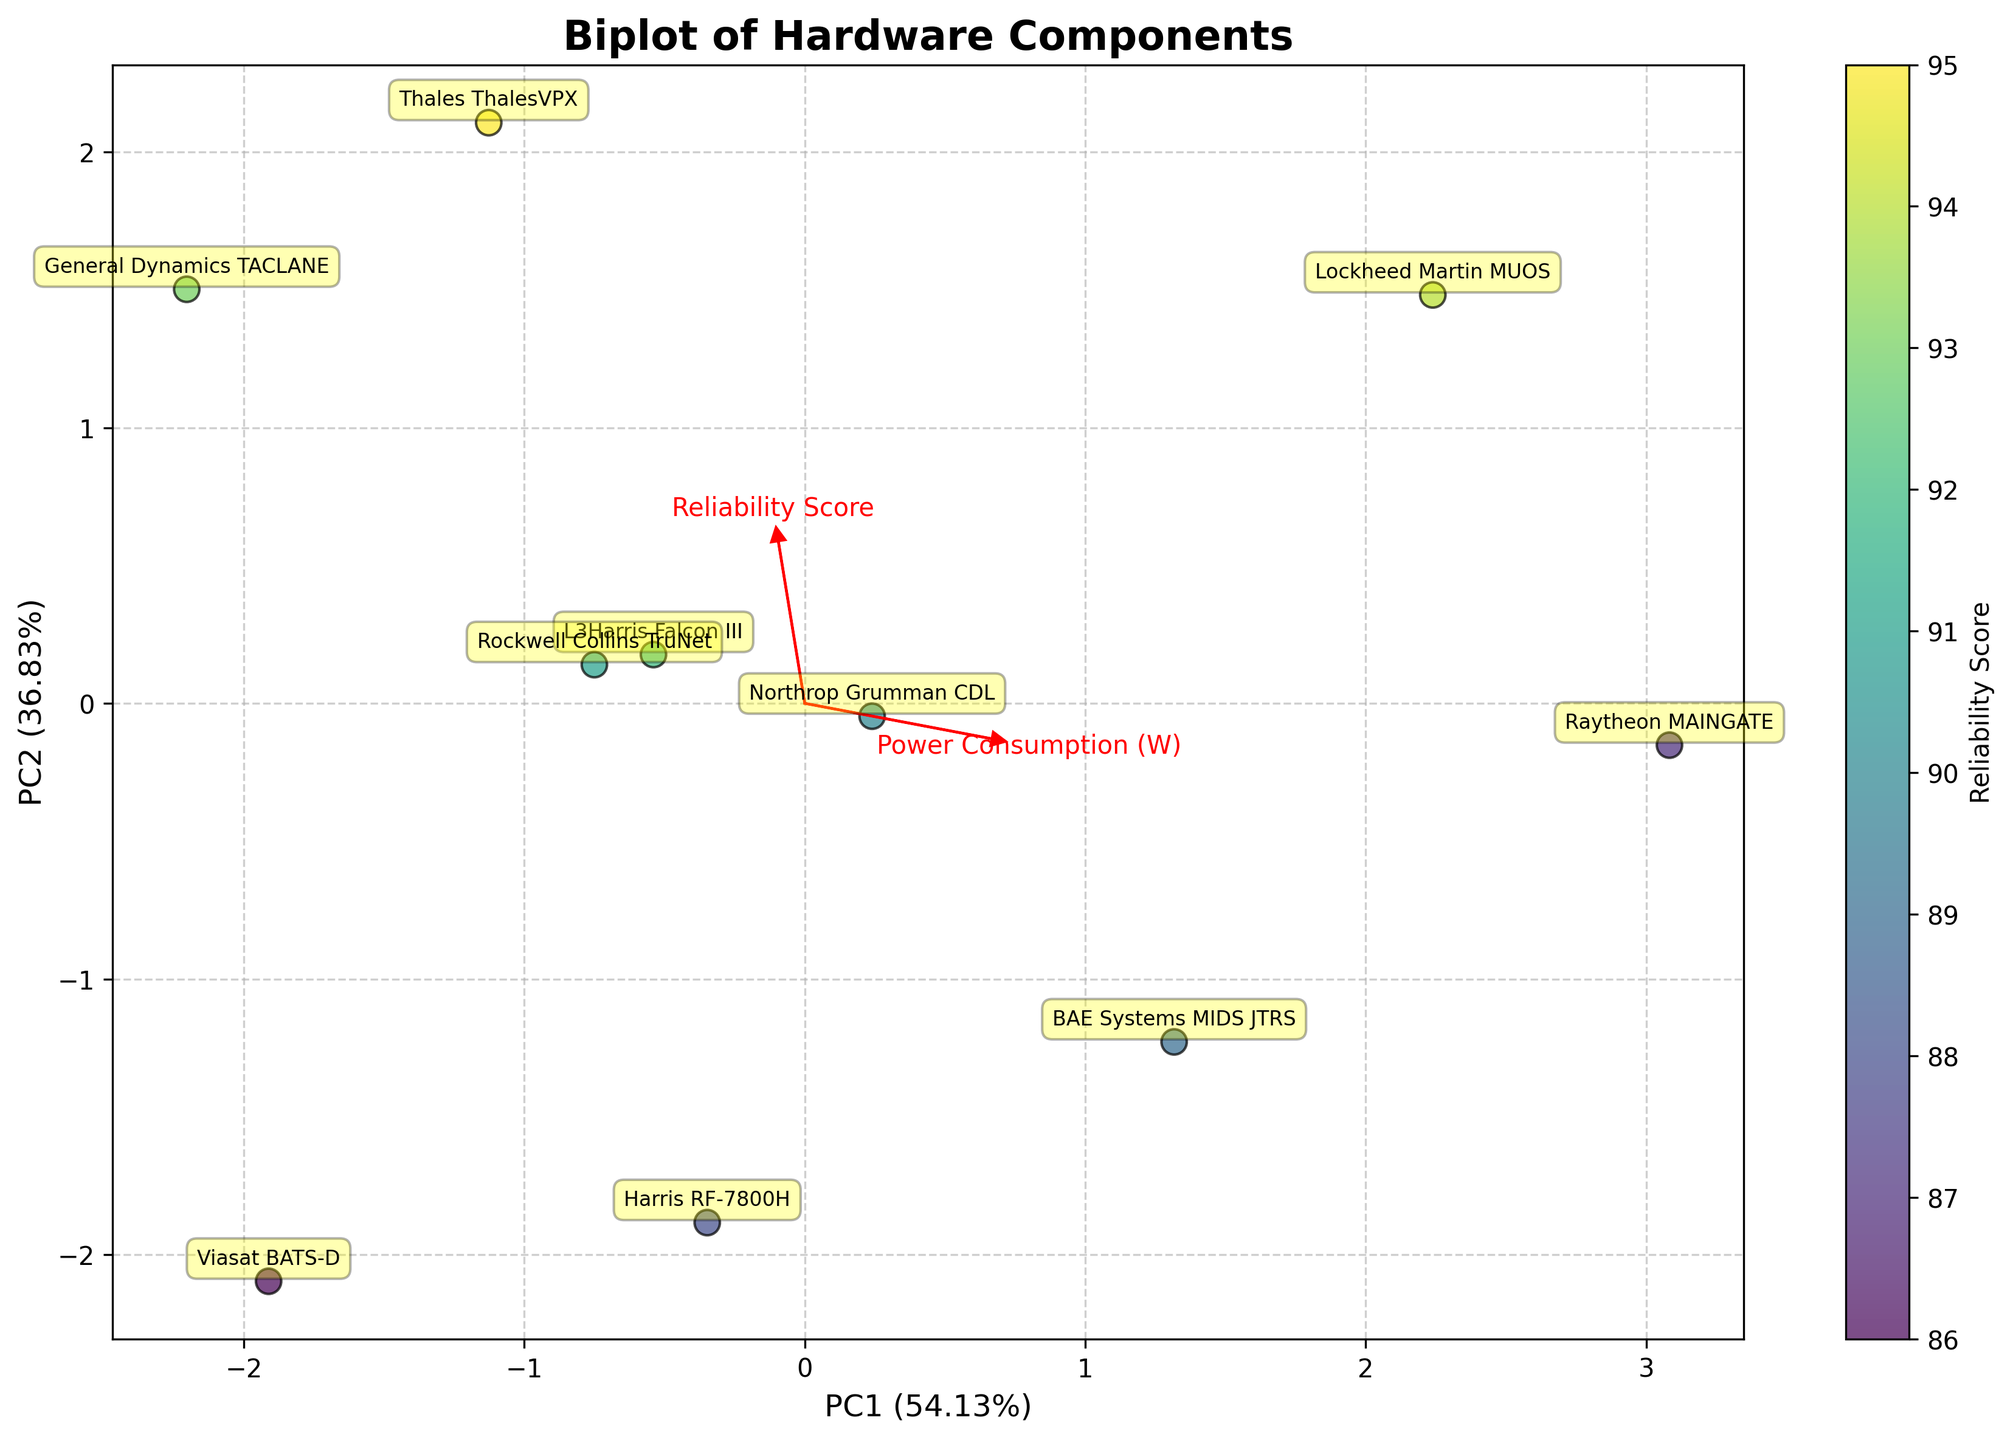What is the title of the plot? The title of the plot is usually centered at the top of the figure and describes the main theme or objective. Here, it is clearly mentioned as "Biplot of Hardware Components".
Answer: Biplot of Hardware Components How many components are represented in the figure? Each component is marked with its name, and we can count these annotations to determine the number of components. By counting, we see that there are 10 components listed.
Answer: 10 Which component has the highest reliability score? The color bar on the right of the plot represents the reliability score. The component with the highest reliability score will have the lightest color. "Thales ThalesVPX" has the highest reliability score with a value of 95, as shown in the color bar.
Answer: Thales ThalesVPX Which two components are closest to each other in the PCA biplot? By observing the relative positions of the component labels in the biplot, "Northrop Grumman CDL" and "L3Harris Falcon III" are closest to each other. Their points are very near to each other visually.
Answer: Northrop Grumman CDL and L3Harris Falcon III List the components that have an encryption level of 256. The components with an encryption level of 256 are aligned along the arrow labeled "Encryption Level" along the positive direction. These components include "Thales ThalesVPX", "Raytheon MAINGATE", "General Dynamics TACLANE", and "Lockheed Martin MUOS".
Answer: Thales ThalesVPX, Raytheon MAINGATE, General Dynamics TACLANE, Lockheed Martin MUOS Which component has the highest heat dissipation, and how can you tell? The component with the highest heat dissipation will align closest to the arrow labeled "Heat Dissipation (C)" at the positive end. "Raytheon MAINGATE" is positioned highest based on heat dissipation according to its location relative to the arrow.
Answer: Raytheon MAINGATE Which feature has the most significant influence on PC2 (second principal component)? The feature with the largest vector pointed in the direction of PC2 has the most significant influence. By observing vector orientations, "Data Rate (Mbps)" has the largest arrow aligned with PC2.
Answer: Data Rate (Mbps) Which two features are most strongly correlated? Features with arrows pointing in the same or opposite directions are highly correlated. "Heat Dissipation (C)" and "Power Consumption (W)" have arrows pointing in almost the same direction, indicating a strong positive correlation.
Answer: Heat Dissipation (C) and Power Consumption (W) What is the relative position of "Viasat BATS-D" concerning "General Dynamics TACLANE"? To find the relative position, we check the coordinates for both components. "Viasat BATS-D" is located more to the left and below "General Dynamics TACLANE" on the biplot, indicating lower PC1 and PC2 values.
Answer: Viasat BATS-D is to the left and below General Dynamics TACLANE What percentage of the total variance is explained by the first two principal components? The x-axis and y-axis labels show the explained variance ratio. The summed variance of PC1 and PC2 is 60% + 20%, which totals 80%.
Answer: 80% 